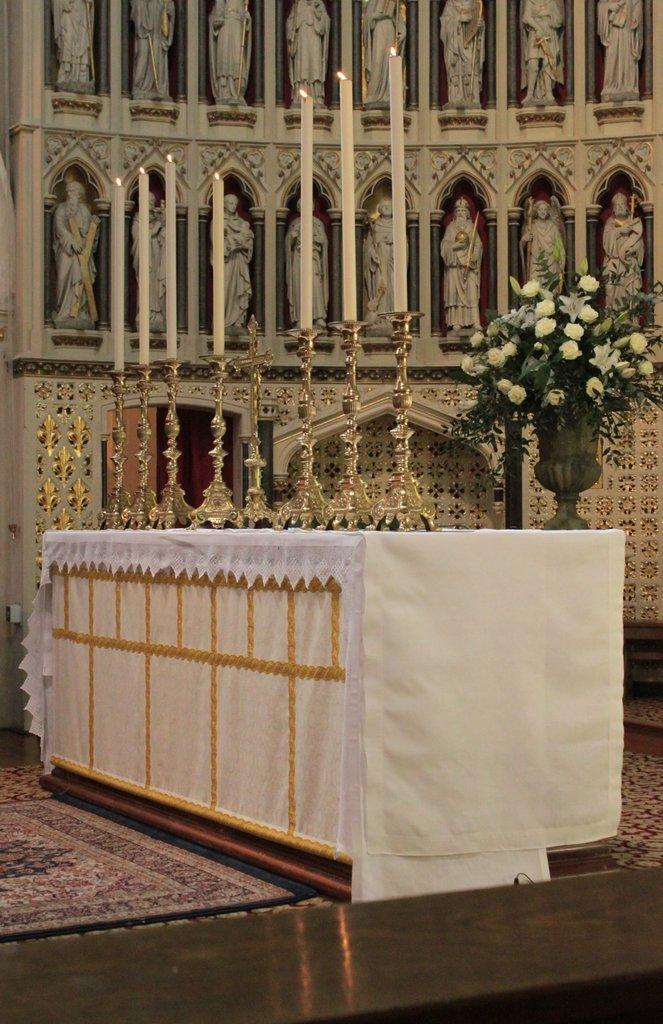What objects are present on the table in the image? There are many candles on the table. How are the candles arranged on the table? The candles are placed one after the other. Where is the man riding the horses in the image? There are no men or horses present in the image; it only features candles on a table. 